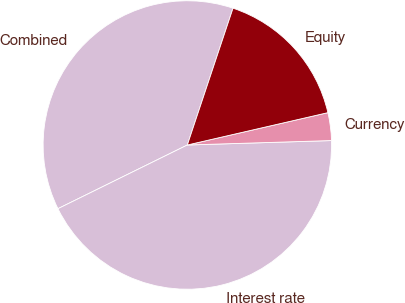<chart> <loc_0><loc_0><loc_500><loc_500><pie_chart><fcel>Combined<fcel>Interest rate<fcel>Currency<fcel>Equity<nl><fcel>37.41%<fcel>43.21%<fcel>3.11%<fcel>16.27%<nl></chart> 